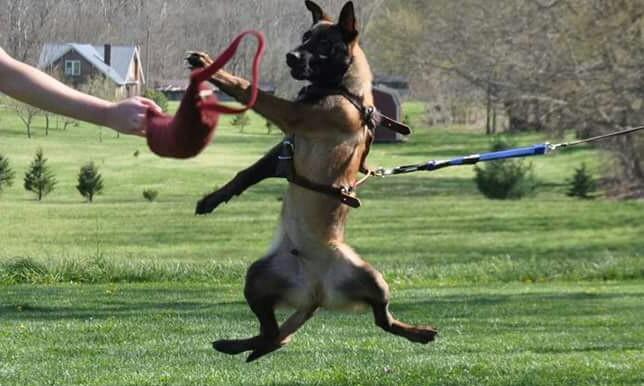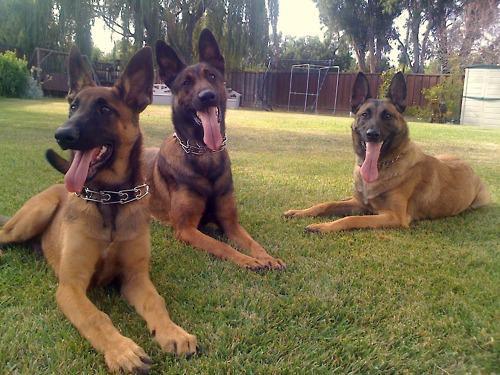The first image is the image on the left, the second image is the image on the right. Given the left and right images, does the statement "An image shows an arm extending something to a german shepherd on a leash." hold true? Answer yes or no. Yes. The first image is the image on the left, the second image is the image on the right. Assess this claim about the two images: "One of the images contains more than one dog.". Correct or not? Answer yes or no. Yes. The first image is the image on the left, the second image is the image on the right. Assess this claim about the two images: "At least one of the dogs is actively moving by running, jumping, or walking.". Correct or not? Answer yes or no. Yes. 